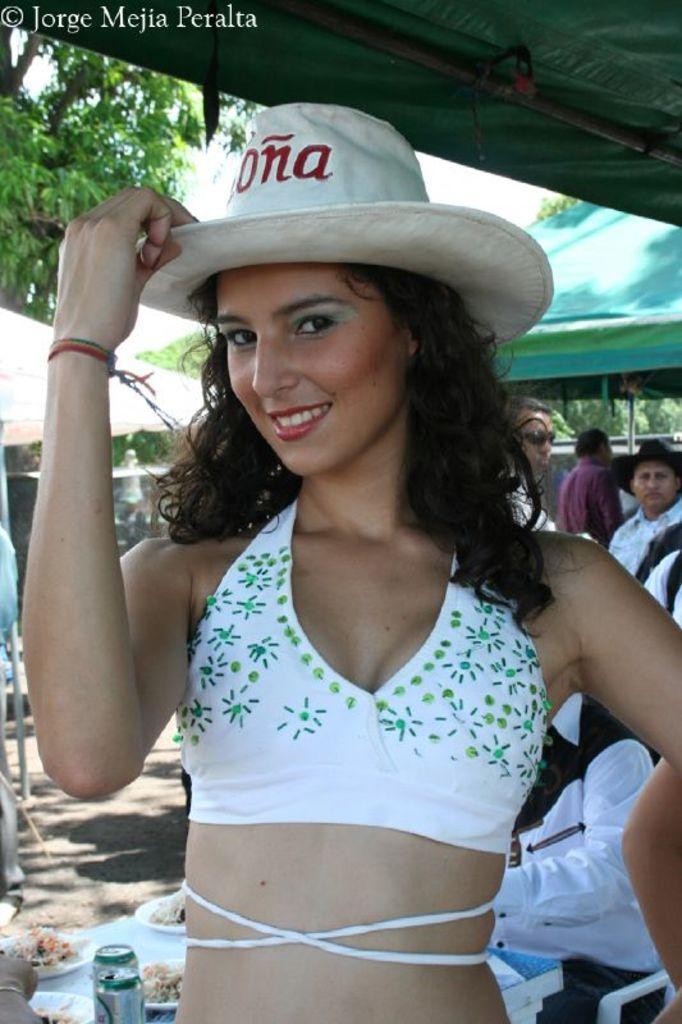In one or two sentences, can you explain what this image depicts? The picture is taken outside a city. In the foreground there is a woman in white dress and hat, behind her there is a table, on the table there are plates served with food. On the right there are people. In the background there are tents and trees. It is sunny day 